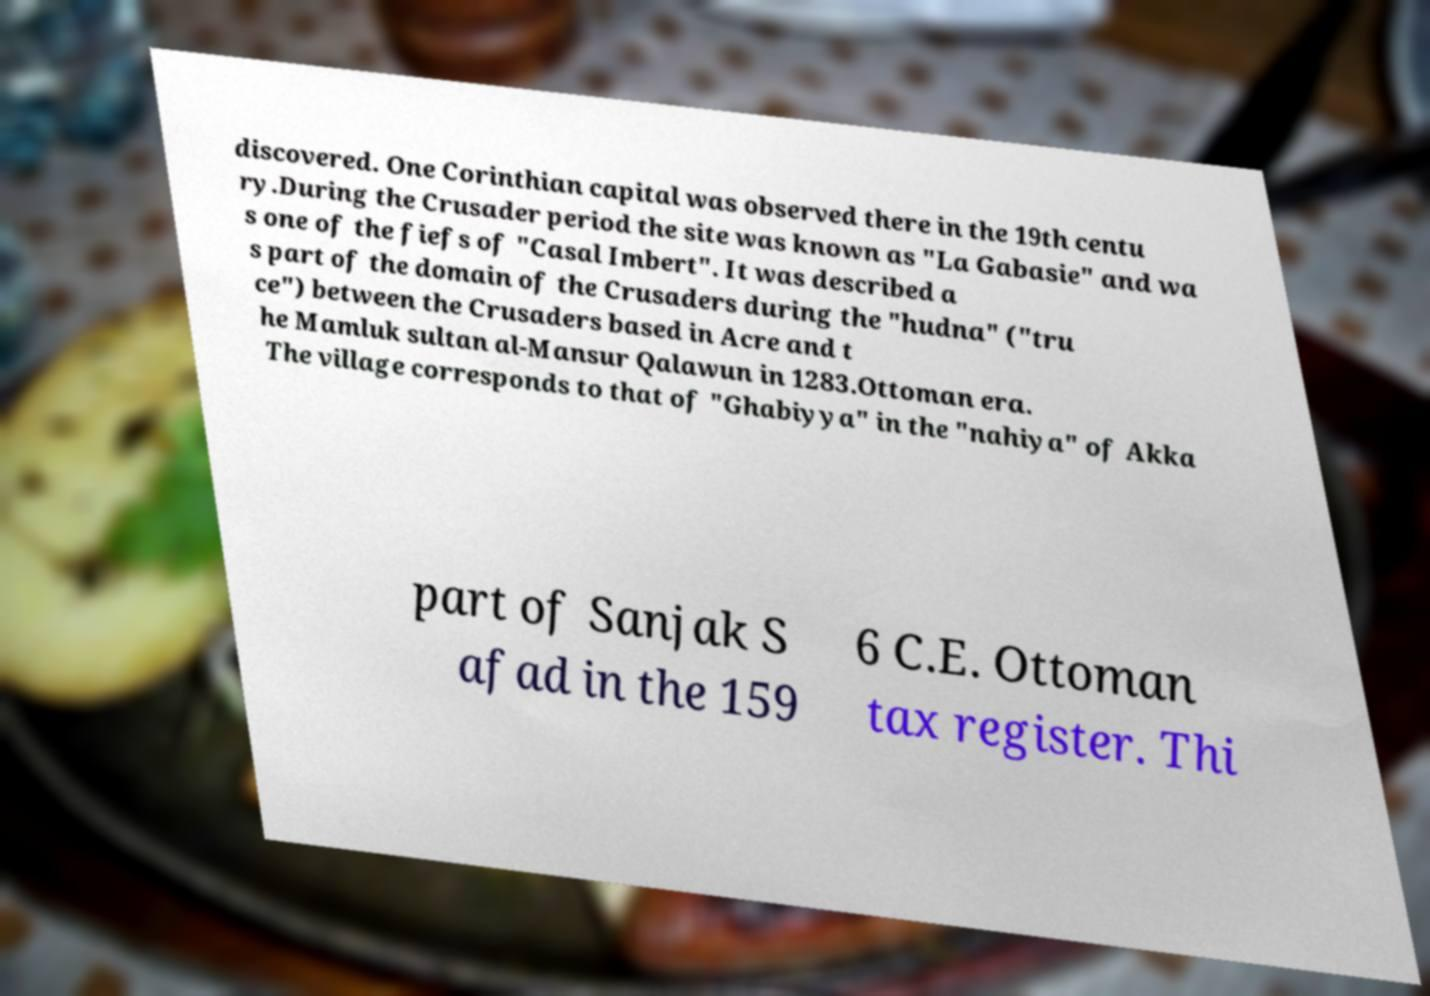Could you assist in decoding the text presented in this image and type it out clearly? discovered. One Corinthian capital was observed there in the 19th centu ry.During the Crusader period the site was known as "La Gabasie" and wa s one of the fiefs of "Casal Imbert". It was described a s part of the domain of the Crusaders during the "hudna" ("tru ce") between the Crusaders based in Acre and t he Mamluk sultan al-Mansur Qalawun in 1283.Ottoman era. The village corresponds to that of "Ghabiyya" in the "nahiya" of Akka part of Sanjak S afad in the 159 6 C.E. Ottoman tax register. Thi 